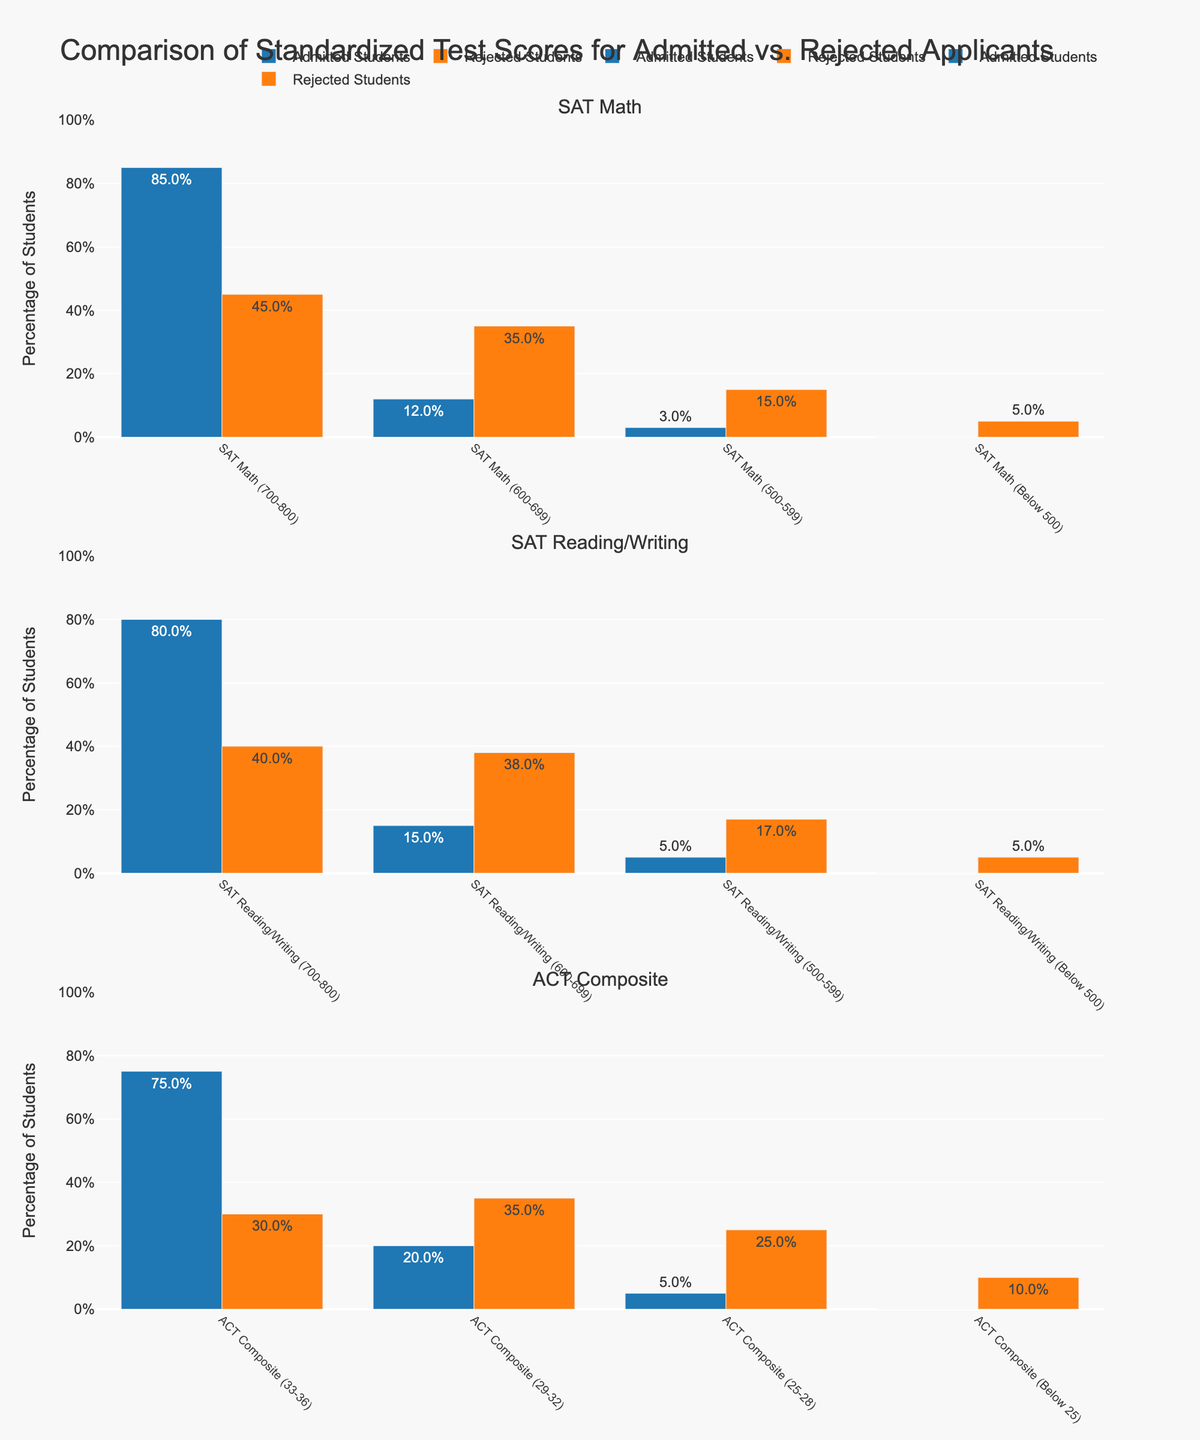What's the percentage difference in SAT Math (700-800) scores between admitted and rejected students? The admitted students' percentage for SAT Math (700-800) scores is 85%, while for rejected students, it is 45%. The difference is calculated as 85% - 45% = 40%.
Answer: 40% Which group has a higher percentage of students with SAT Reading/Writing scores in the range of 500-599? For SAT Reading/Writing scores between 500-599, the percentage of admitted students is 5%, and for rejected students, it is 17%. 17% is greater than 5%.
Answer: Rejected Students How many test score categories have 0% for admitted students? The categories with 0% admitted students are SAT Math (Below 500), SAT Reading/Writing (Below 500), and ACT Composite (Below 25). There are 3 such categories.
Answer: 3 Which test type had the smallest percentage difference between admitted and rejected students in the highest score range? The highest score range for SAT Math (700-800) difference is 40%, SAT Reading/Writing (700-800) difference is 40%, and ACT Composite (33-36) difference is 45%. The smallest difference is for SAT Math and SAT Reading/Writing, both with 40%.
Answer: SAT Math and SAT Reading/Writing In the ACT Composite (25-28) range, what is the combined percentage of admitted and rejected students? For ACT Composite (25-28), the admitted percentage is 5% and the rejected percentage is 25%. The combined percentage is 5% + 25% = 30%.
Answer: 30% What's the ratio of admitted to rejected students for SAT Math (600-699) scores? The percentages are 12% for admitted students and 35% for rejected students. The ratio of admitted to rejected is 12:35.
Answer: 12:35 How does the percentage of admitted students with ACT Composite scores (33-36) compare to that of rejected students in the same range? The percentage of admitted students is 75% and for rejected students, it is 30%. 75% is higher than 30%.
Answer: Higher What's the total percentage of admitted students across all SAT (Math and Reading/Writing) and ACT Composite categories with scores above 700 for SAT or above 32 for ACT? Admitted students percentages are SAT Math (700-800) 85%, SAT Reading/Writing (700-800) 80%, ACT Composite (33-36) 75%. Total is 85% + 80% + 75% = 240%.
Answer: 240% 